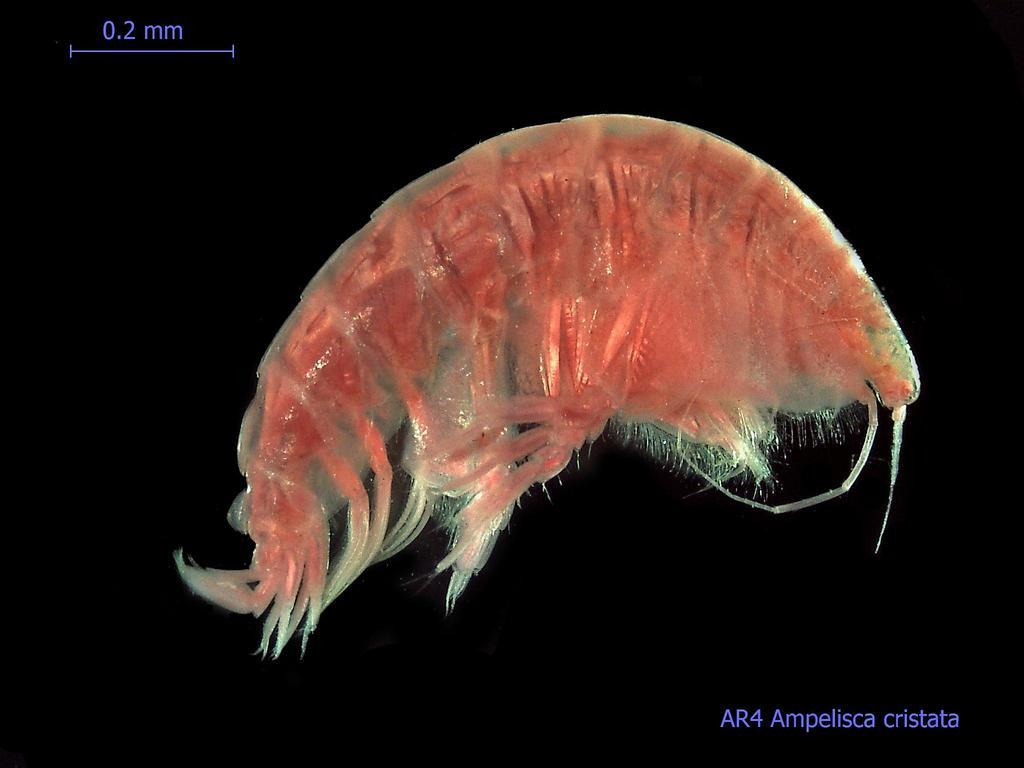What is the main subject of the image? The main subject of the image is a prawn. Where is the prawn located in the image? The prawn is on a screen. What type of glass is the prawn drinking from in the image? There is no glass present in the image, and the prawn is not shown drinking from anything. 